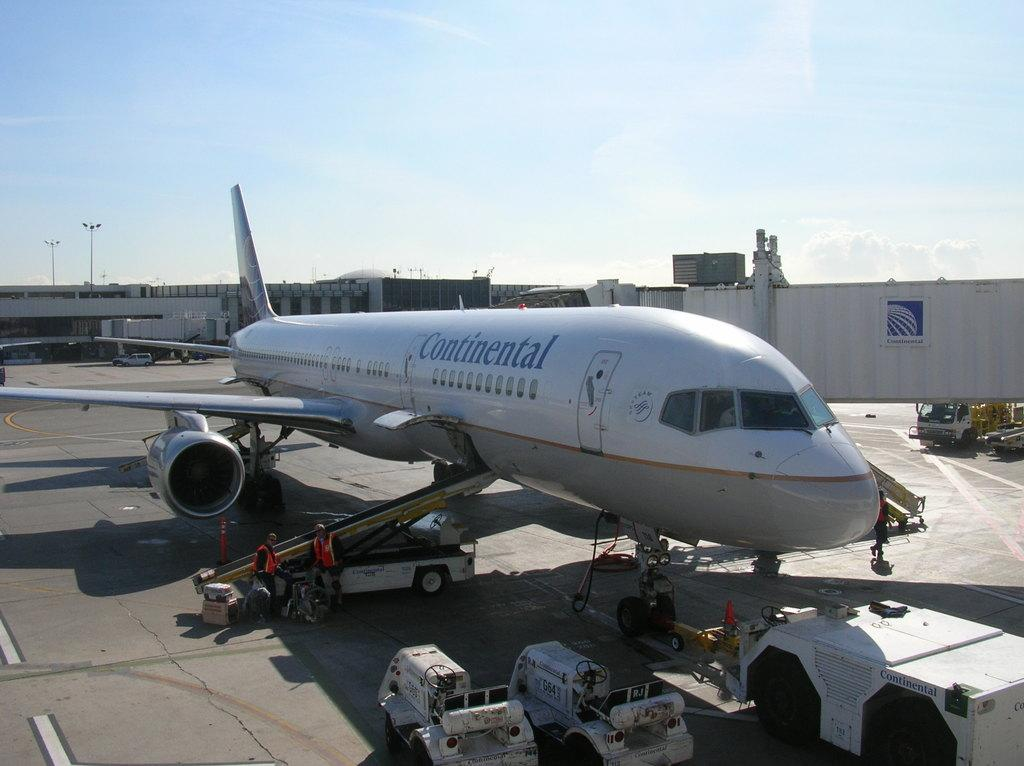<image>
Share a concise interpretation of the image provided. A large Continental jet is being loaded on the tarmac. 